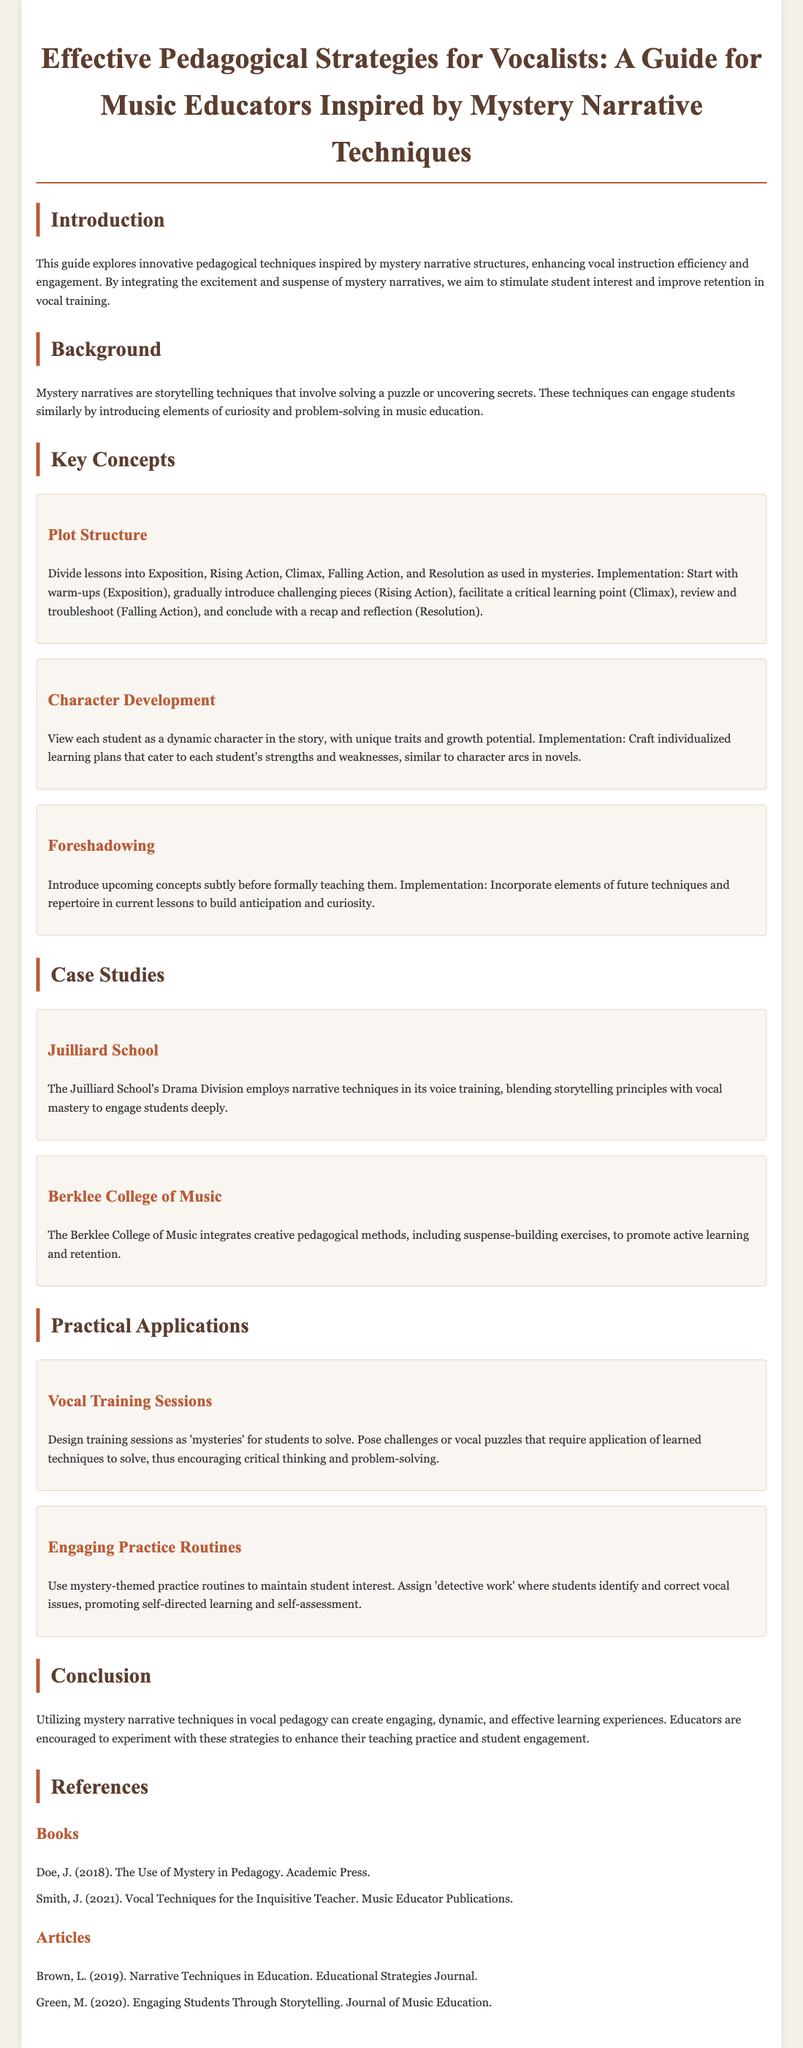What is the title of the guide? The title of the guide is mentioned at the beginning of the document.
Answer: Effective Pedagogical Strategies for Vocalists: A Guide for Music Educators Inspired by Mystery Narrative Techniques What are the key components of the plot structure? The document lists the components of plot structure in vocal lessons.
Answer: Exposition, Rising Action, Climax, Falling Action, Resolution Which institution employs narrative techniques in voice training? The document provides specific examples of institutions using these techniques.
Answer: Juilliard School What strategy encourages critical thinking in vocal training sessions? The document lists specific methods that enhance learning in vocal training.
Answer: Design training sessions as 'mysteries' Who authored the book "The Use of Mystery in Pedagogy"? The references section lists authors and their works.
Answer: Doe, J What is one intended outcome of using mystery narratives in pedagogy? The guide discusses the overall goal of integrating mystery narratives into teaching.
Answer: Enhance student engagement 